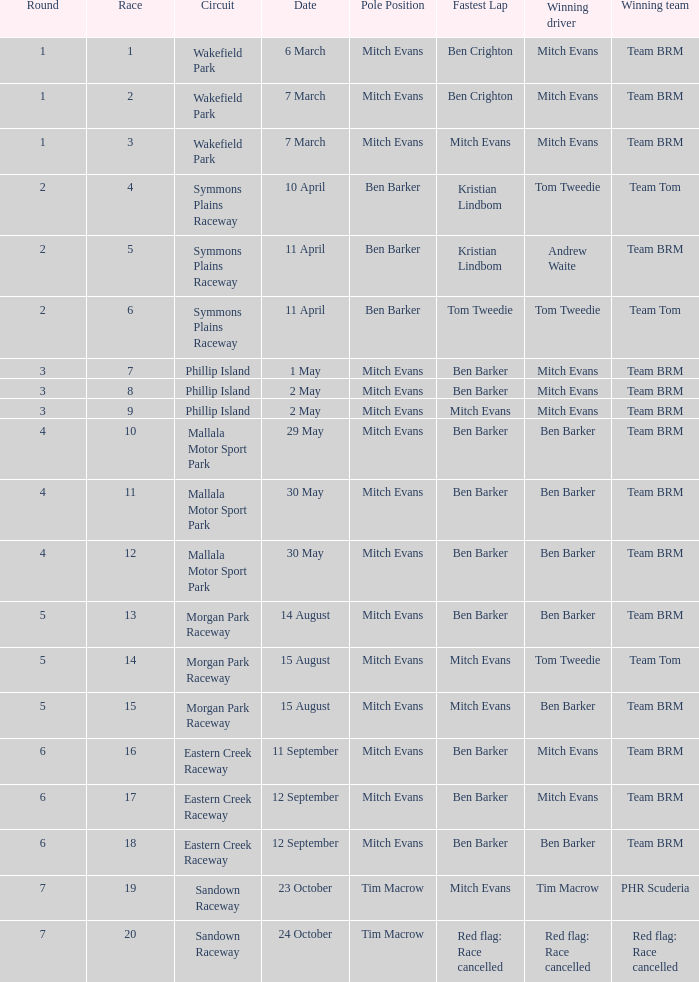What group claimed victory in race 17? Team BRM. 